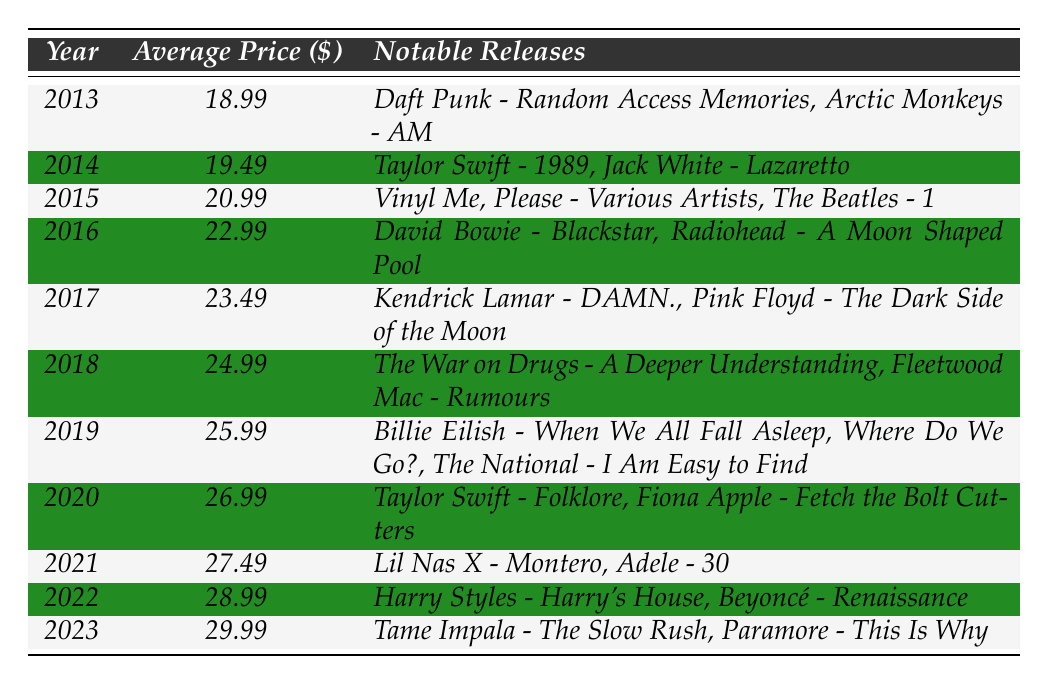What was the average price of vinyl records in 2015? The table shows that the average price of vinyl records in 2015 was $20.99.
Answer: $20.99 Which year had the highest average price for vinyl records? According to the table, the highest average price, $29.99, occurred in 2023.
Answer: 2023 What notable release is listed for the year 2019? In the year 2019, the notable releases were "Billie Eilish - When We All Fall Asleep, Where Do We Go?" and "The National - I Am Easy to Find."
Answer: Billie Eilish - When We All Fall Asleep, Where Do We Go? What was the increase in average price from 2013 to 2023? The average price in 2013 was $18.99 and in 2023 it was $29.99. The increase is $29.99 - $18.99 = $11.00.
Answer: $11.00 Did the average price decrease at any point during the decade? By examining the table for each year's prices, there were no years with a decrease; the trend was consistently upward.
Answer: No What is the average price of vinyl records from 2015 to 2020? The average prices for those years are $20.99 (2015), $22.99 (2016), $23.49 (2017), $24.99 (2018), $25.99 (2019), and $26.99 (2020). Summing these gives $145.44. Dividing by 6 years gives an average price of $24.24.
Answer: $24.24 Which year had the lowest average price, and what was it? The year with the lowest average price, $18.99, is identified in the table as 2013.
Answer: 2013, $18.99 How many notable releases listed for 2022? The table lists two notable releases for 2022: "Harry Styles - Harry's House" and "Beyoncé - Renaissance."
Answer: 2 What is the difference in average price between 2021 and 2022? The average price in 2021 was $27.49 and in 2022 it was $28.99. The difference is $28.99 - $27.49 = $1.50.
Answer: $1.50 Which artist had a notable release in both 2014 and 2020? The artist Taylor Swift had notable releases in 2014 with "1989" and in 2020 with "Folklore."
Answer: Taylor Swift 